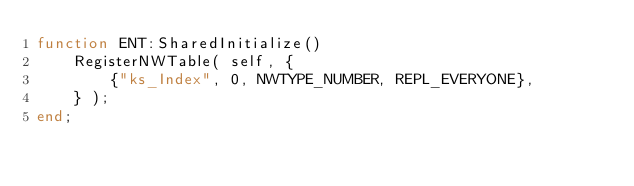<code> <loc_0><loc_0><loc_500><loc_500><_Lua_>function ENT:SharedInitialize()
	RegisterNWTable( self, {
		{"ks_Index", 0, NWTYPE_NUMBER, REPL_EVERYONE},
	} );
end;</code> 